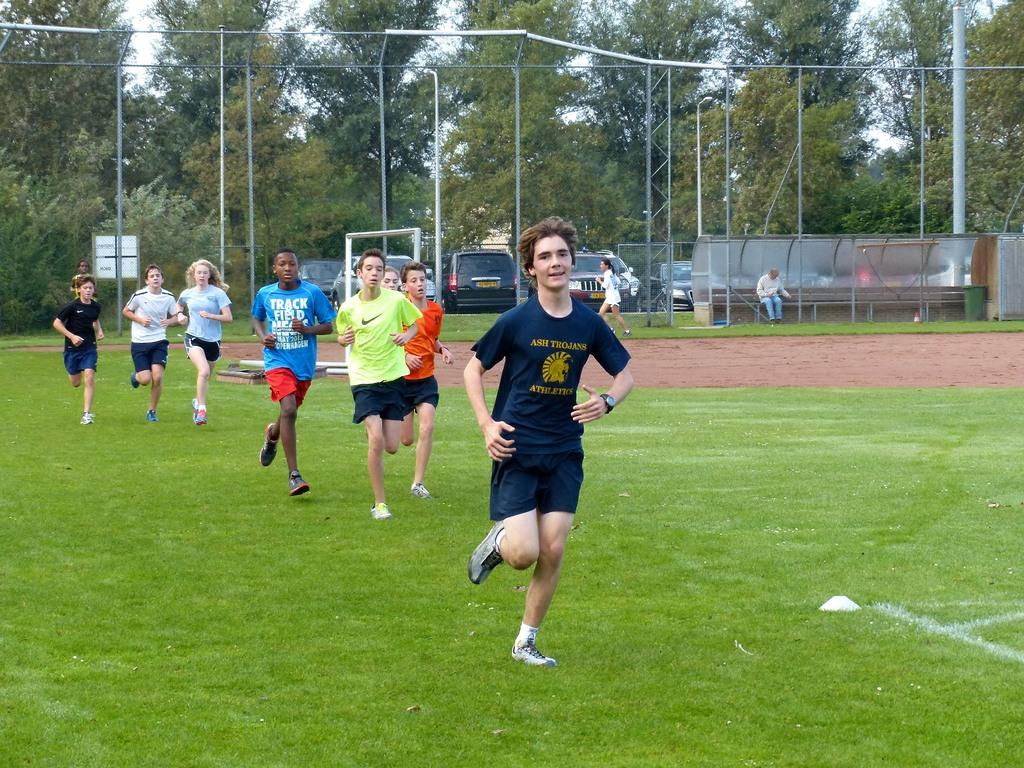<image>
Create a compact narrative representing the image presented. Students running on a grass field, the leader of the pack is wearing a shirt that says Ash Trojans Athletics. 